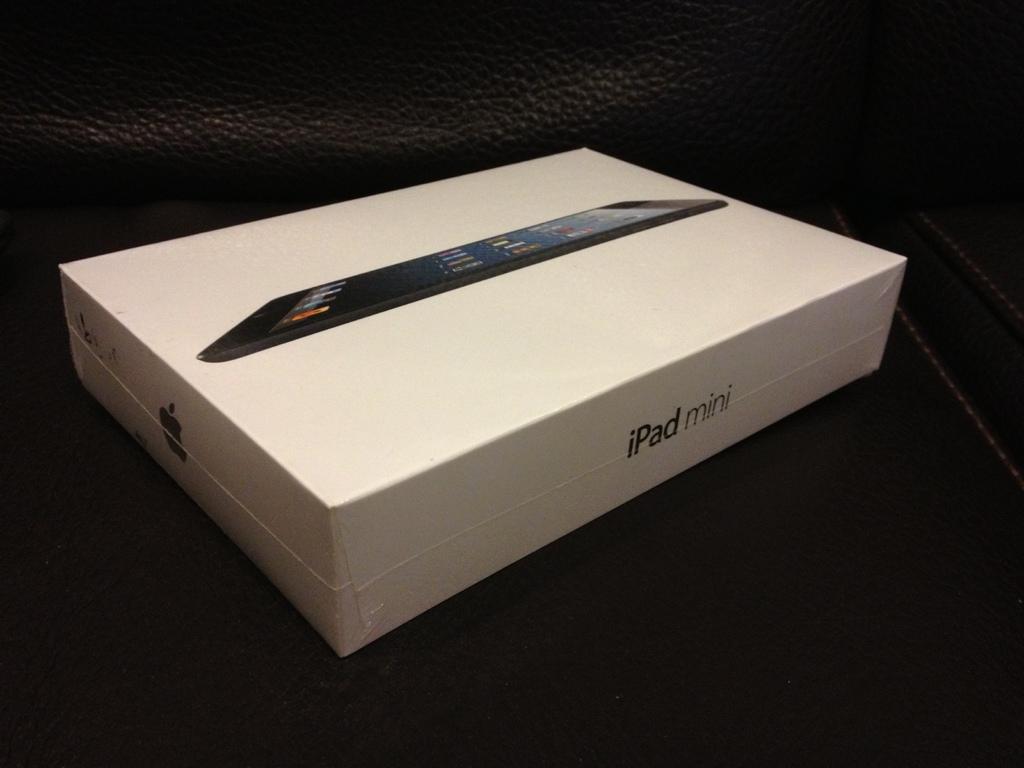What brand of ipad?
Your answer should be very brief. Mini. What is the brand of this tablet?
Your answer should be compact. Ipad. 